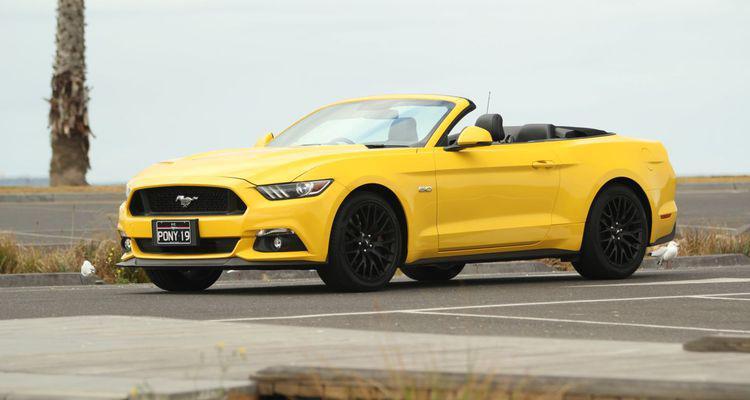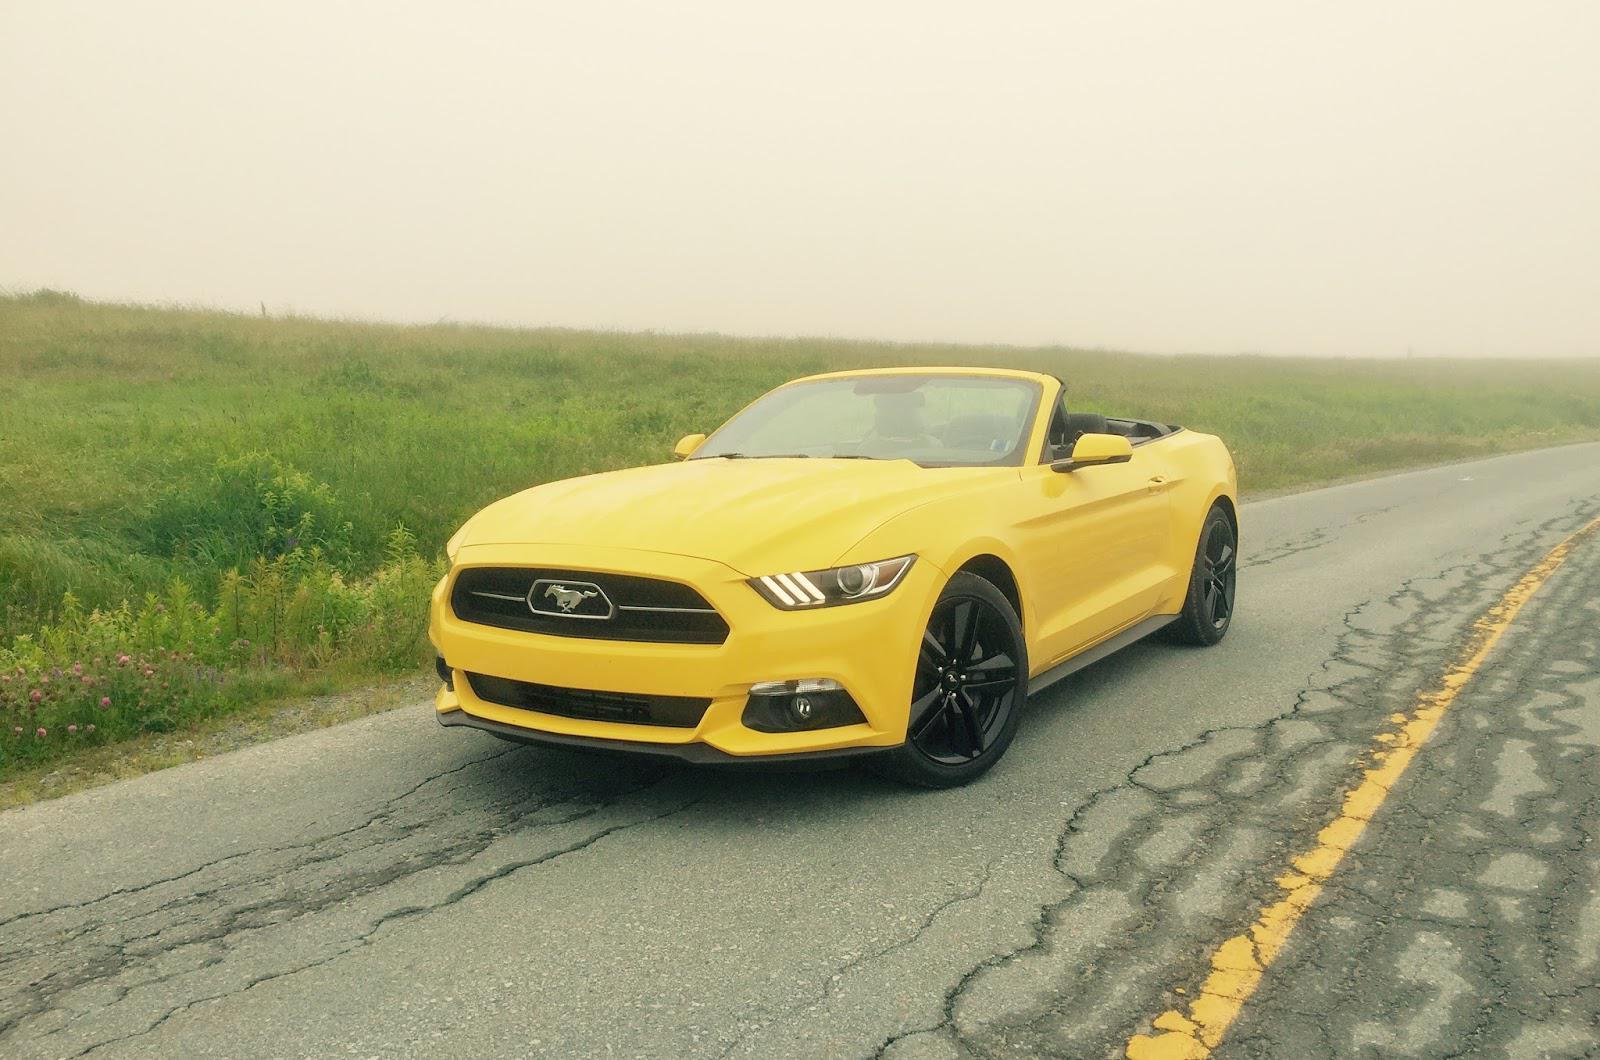The first image is the image on the left, the second image is the image on the right. Evaluate the accuracy of this statement regarding the images: "There are two yellow convertibles facing to the right.". Is it true? Answer yes or no. No. The first image is the image on the left, the second image is the image on the right. For the images displayed, is the sentence "Black stripes are visible on the hood of a yellow convertible aimed rightward." factually correct? Answer yes or no. No. 